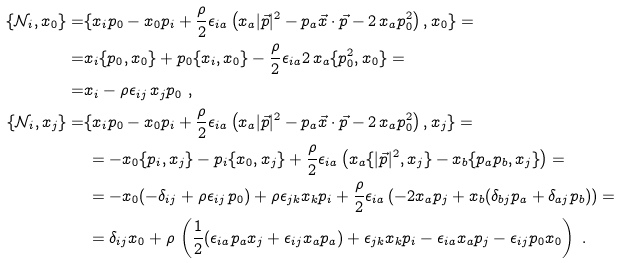<formula> <loc_0><loc_0><loc_500><loc_500>\{ \mathcal { N } _ { i } , x _ { 0 } \} = & \{ x _ { i } p _ { 0 } - x _ { 0 } p _ { i } + \frac { \rho } { 2 } \epsilon _ { i a } \left ( x _ { a } | \vec { p } | ^ { 2 } - p _ { a } \vec { x } \cdot \vec { p } - 2 \, x _ { a } p ^ { 2 } _ { 0 } \right ) , x _ { 0 } \} = \\ = & x _ { i } \{ p _ { 0 } , x _ { 0 } \} + p _ { 0 } \{ x _ { i } , x _ { 0 } \} - \frac { \rho } { 2 } \epsilon _ { i a } 2 \, x _ { a } \{ p ^ { 2 } _ { 0 } , x _ { 0 } \} = \\ = & x _ { i } - \rho \epsilon _ { i j } \, x _ { j } p _ { 0 } \ , \\ \{ \mathcal { N } _ { i } , x _ { j } \} = & \{ x _ { i } p _ { 0 } - x _ { 0 } p _ { i } + \frac { \rho } { 2 } \epsilon _ { i a } \left ( x _ { a } | \vec { p } | ^ { 2 } - p _ { a } \vec { x } \cdot \vec { p } - 2 \, x _ { a } p ^ { 2 } _ { 0 } \right ) , x _ { j } \} = \\ & \, = - x _ { 0 } \{ p _ { i } , x _ { j } \} - p _ { i } \{ x _ { 0 } , x _ { j } \} + \frac { \rho } { 2 } \epsilon _ { i a } \left ( x _ { a } \{ | \vec { p } | ^ { 2 } , x _ { j } \} - x _ { b } \{ p _ { a } p _ { b } , x _ { j } \} \right ) = \\ & \, = - x _ { 0 } ( - \delta _ { i j } + \rho \epsilon _ { i j } \, p _ { 0 } ) + \rho \epsilon _ { j k } x _ { k } p _ { i } + \frac { \rho } { 2 } \epsilon _ { i a } \left ( - 2 x _ { a } p _ { j } + x _ { b } ( \delta _ { b j } p _ { a } + \delta _ { a j } p _ { b } ) \right ) = \\ & \, = \delta _ { i j } x _ { 0 } + \rho \, \left ( \frac { 1 } { 2 } ( \epsilon _ { i a } p _ { a } x _ { j } + \epsilon _ { i j } x _ { a } p _ { a } ) + \epsilon _ { j k } x _ { k } p _ { i } - \epsilon _ { i a } x _ { a } p _ { j } - \epsilon _ { i j } p _ { 0 } x _ { 0 } \right ) \ .</formula> 